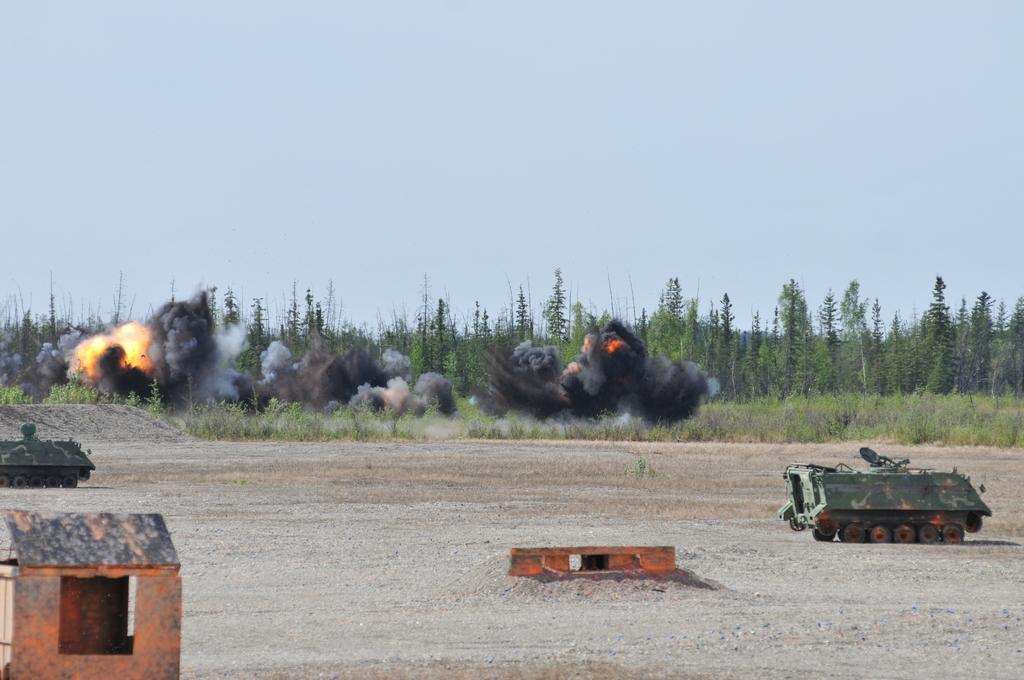What types of vehicles can be seen in the image? There are vehicles in the image, but the specific types are not mentioned. What is on the ground in the image? There are objects on the ground in the image, but their nature is not specified. What is causing the fire in the image? The cause of the fire is not mentioned in the provided facts. How does the smoke appear in the image? The smoke is present in the image, but its origin or distribution is not described. What can be seen in the background of the image? There are trees visible in the background of the image. What direction is the rat running in the image? There is no rat present in the image, so this question cannot be answered. 